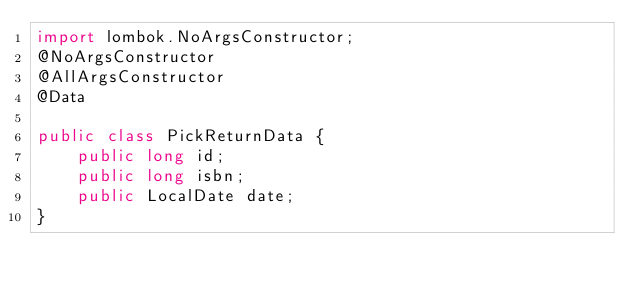Convert code to text. <code><loc_0><loc_0><loc_500><loc_500><_Java_>import lombok.NoArgsConstructor;
@NoArgsConstructor
@AllArgsConstructor
@Data

public class PickReturnData {
	public long id;
	public long isbn;
	public LocalDate date;
}
</code> 